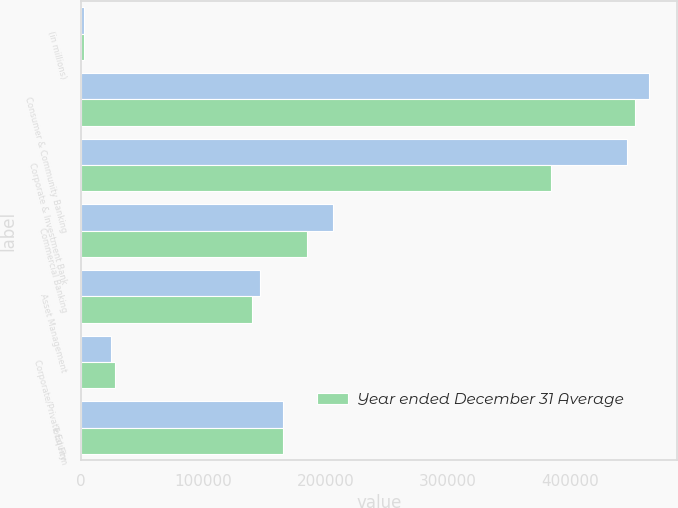Convert chart to OTSL. <chart><loc_0><loc_0><loc_500><loc_500><stacked_bar_chart><ecel><fcel>(in millions)<fcel>Consumer & Community Banking<fcel>Corporate & Investment Bank<fcel>Commercial Banking<fcel>Asset Management<fcel>Corporate/Private Equity<fcel>Total Firm<nl><fcel>nan<fcel>2013<fcel>464412<fcel>446237<fcel>206127<fcel>146183<fcel>24806<fcel>165296<nl><fcel>Year ended December 31 Average<fcel>2013<fcel>453304<fcel>384289<fcel>184409<fcel>139707<fcel>27433<fcel>165296<nl></chart> 